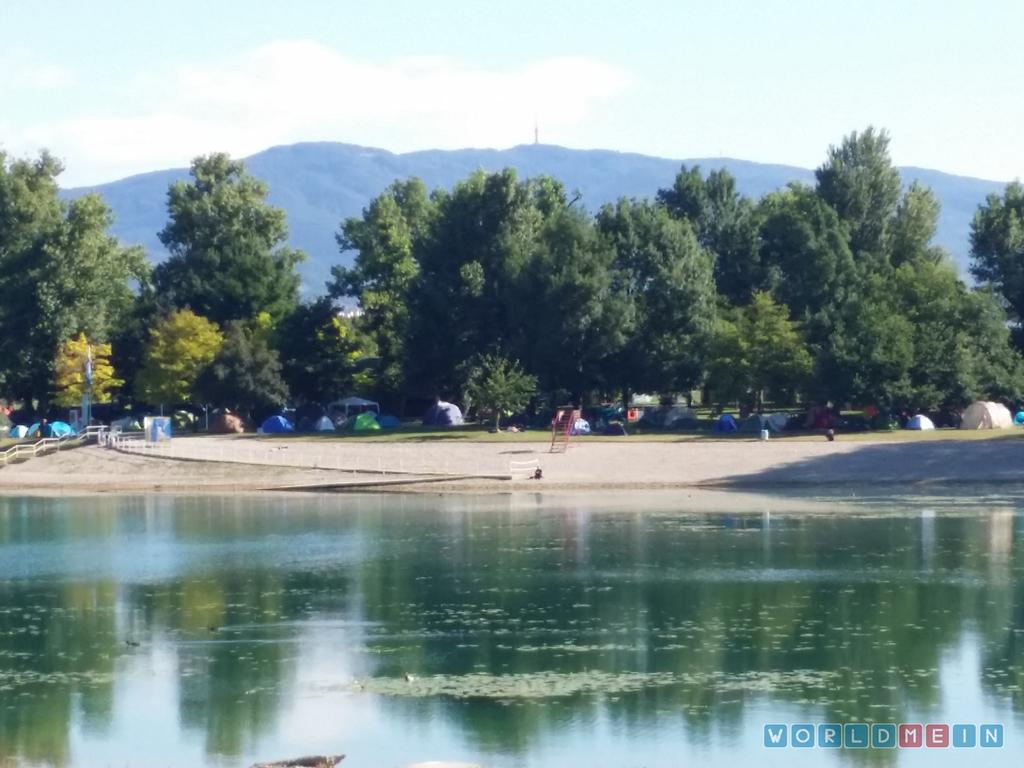What is present at the bottom of the image? There is water at the bottom of the image. What can be seen in the distance in the image? There are trees in the background of the image. What type of geographical feature is visible in the image? There are mountains in the image. What type of honey can be seen dripping from the trees in the image? There is no honey present in the image; it features water, trees, and mountains. How many quarters are visible on the mountains in the image? There are no quarters present in the image; it only features mountains, trees, and water. 